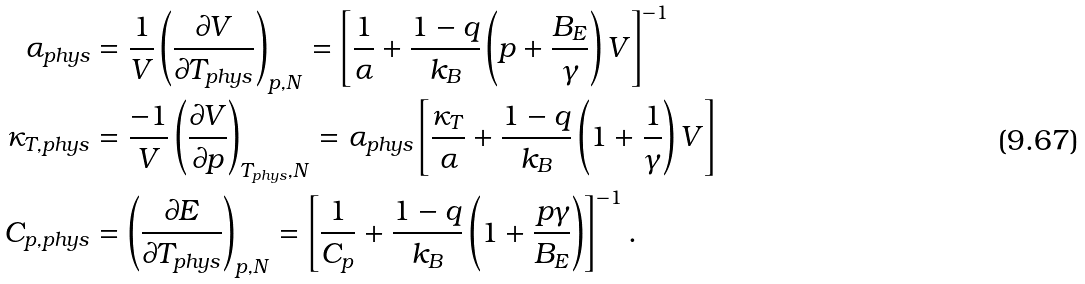Convert formula to latex. <formula><loc_0><loc_0><loc_500><loc_500>\alpha _ { p h y s } & = \frac { 1 } { V } \left ( \frac { \partial V } { \partial T _ { p h y s } } \right ) _ { p , N } = \left [ \frac { 1 } { \alpha } + \frac { 1 - q } { k _ { B } } \left ( p + \frac { B _ { E } } { \gamma } \right ) V \right ] ^ { - 1 } \\ \kappa _ { T , p h y s } & = \frac { - 1 } { V } \left ( \frac { \partial V } { \partial p } \right ) _ { T _ { p h y s } , N } = \alpha _ { p h y s } \left [ \frac { \kappa _ { T } } { \alpha } + \frac { 1 - q } { k _ { B } } \left ( 1 + \frac { 1 } { \gamma } \right ) V \right ] \\ C _ { p , p h y s } & = \left ( \frac { \partial E } { \partial T _ { p h y s } } \right ) _ { p , N } = \left [ \frac { 1 } { C _ { p } } + \frac { 1 - q } { k _ { B } } \left ( 1 + \frac { p \gamma } { B _ { E } } \right ) \right ] ^ { - 1 } .</formula> 